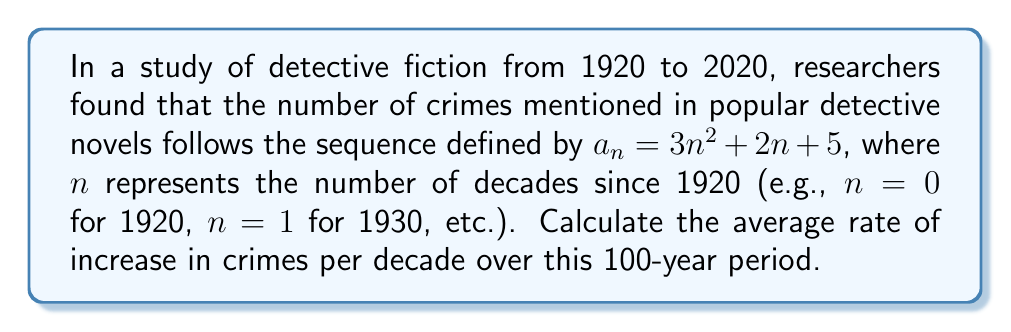Give your solution to this math problem. Let's approach this step-by-step:

1) First, we need to find the number of crimes at the start (1920) and end (2020) of the period:

   For 1920 (n = 0): $a_0 = 3(0)^2 + 2(0) + 5 = 5$
   For 2020 (n = 10): $a_{10} = 3(10)^2 + 2(10) + 5 = 325$

2) The total increase in crimes over the 100-year period is:
   $325 - 5 = 320$

3) To find the average rate of increase per decade, we divide this total increase by the number of decades (10):

   $$\text{Average rate} = \frac{320}{10} = 32$$

4) We can verify this by calculating the arithmetic mean of the first difference of the sequence:

   $$\frac{a_{n+1} - a_n}{(n+1) - n} = 3(n+1)^2 + 2(n+1) + 5 - (3n^2 + 2n + 5)$$
   $$= 3n^2 + 6n + 3 + 2n + 2 + 5 - 3n^2 - 2n - 5$$
   $$= 6n + 5$$

5) The average of this first difference over the 10 decades is:

   $$\frac{1}{10}\sum_{n=0}^{9} (6n + 5) = \frac{1}{10}(6\cdot\frac{9\cdot10}{2} + 5\cdot10) = 32$$

This confirms our earlier calculation.
Answer: 32 crimes per decade 